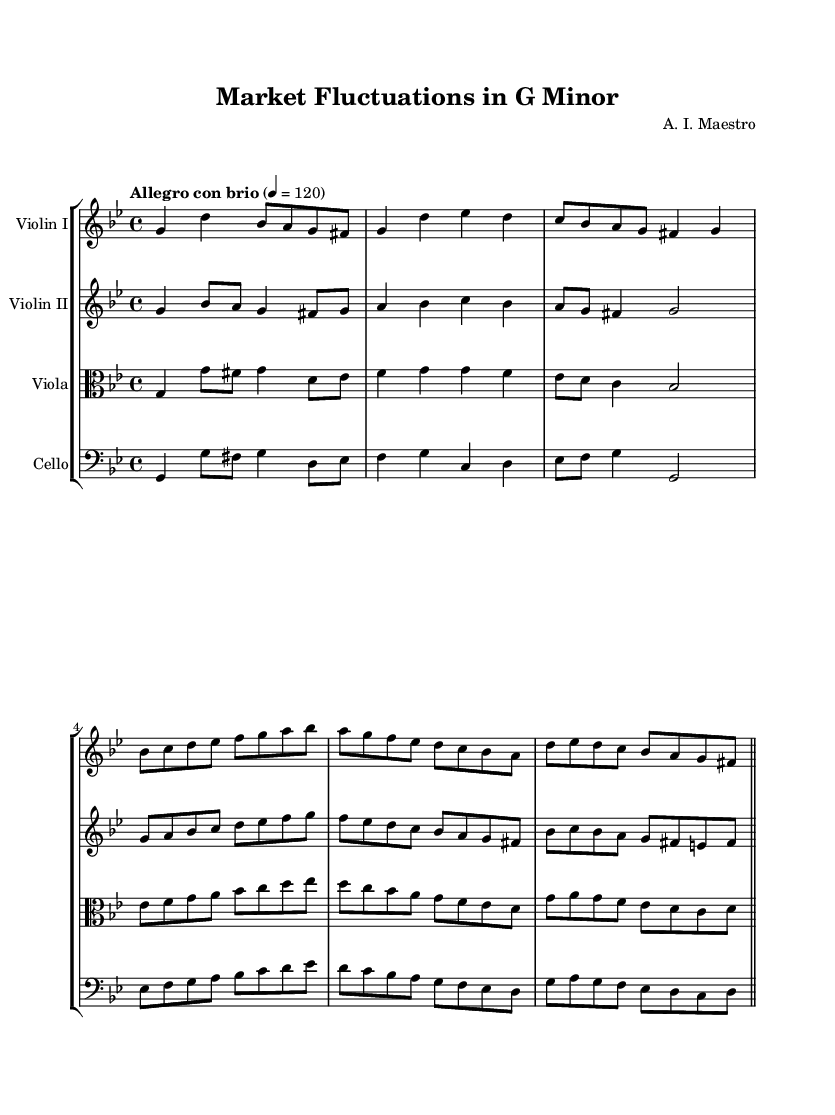What is the key signature of this music? The key signature is G minor, which has two flats (B flat and E flat). This can be determined by looking at the key signature indicated at the beginning of the sheet music.
Answer: G minor What is the time signature used in this composition? The time signature is 4/4, which means there are four beats per measure, and each quarter note receives one beat. This information is found at the beginning of the score, next to the key signature.
Answer: 4/4 What tempo marking is indicated for this piece? The tempo marking is "Allegro con brio," which suggests a fast and lively pace. It is typically stated at the beginning of the composition, close to the global information.
Answer: Allegro con brio How many measures are present in the first violin’s part? The first violin part contains a total of 8 measures, which can be counted by visually observing the bar lines on the staff. Each set of notes between two bar lines constitutes one measure.
Answer: 8 Which instrument has a clef change in the score? The viola has a clef change, as indicated by the clef symbol at the beginning of its part. It uses the alto clef, which is unique to certain instruments like the viola.
Answer: Viola What is the relationship between the first violin and the second violin in terms of harmony? The first and second violins are harmonizing with each other, as they play complementary melodies that often interconnect and support the primary thematic material presented in the score. This relationship can be seen through the matching rhythms and note events in the score.
Answer: Harmonizing Which section of the symphony is characterized by a descent in pitch in the cello part? The cello part features a noticeable descent in pitch during the passage that begins with E sharp and progresses downwards through several notes before returning to G. This can be identified by closely analyzing the descending notes in the score.
Answer: Descent in pitch 